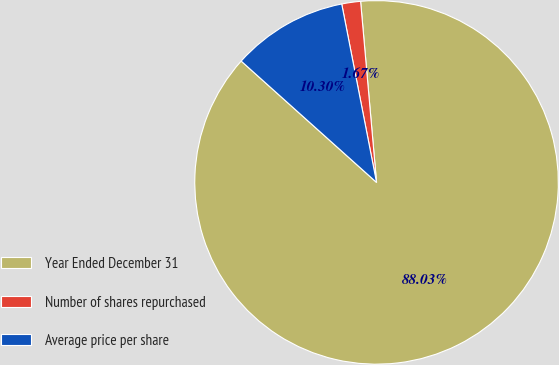Convert chart to OTSL. <chart><loc_0><loc_0><loc_500><loc_500><pie_chart><fcel>Year Ended December 31<fcel>Number of shares repurchased<fcel>Average price per share<nl><fcel>88.03%<fcel>1.67%<fcel>10.3%<nl></chart> 